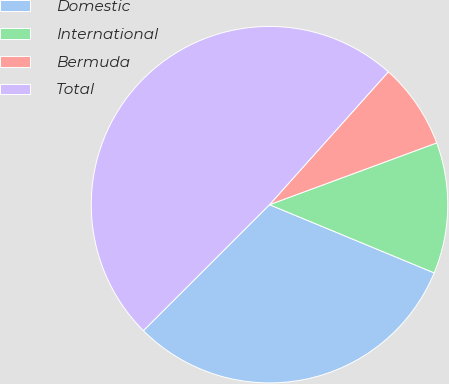Convert chart to OTSL. <chart><loc_0><loc_0><loc_500><loc_500><pie_chart><fcel>Domestic<fcel>International<fcel>Bermuda<fcel>Total<nl><fcel>31.26%<fcel>11.88%<fcel>7.75%<fcel>49.1%<nl></chart> 